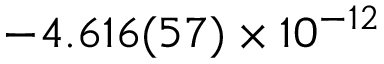Convert formula to latex. <formula><loc_0><loc_0><loc_500><loc_500>- 4 . 6 1 6 ( 5 7 ) \times 1 0 ^ { - 1 2 }</formula> 